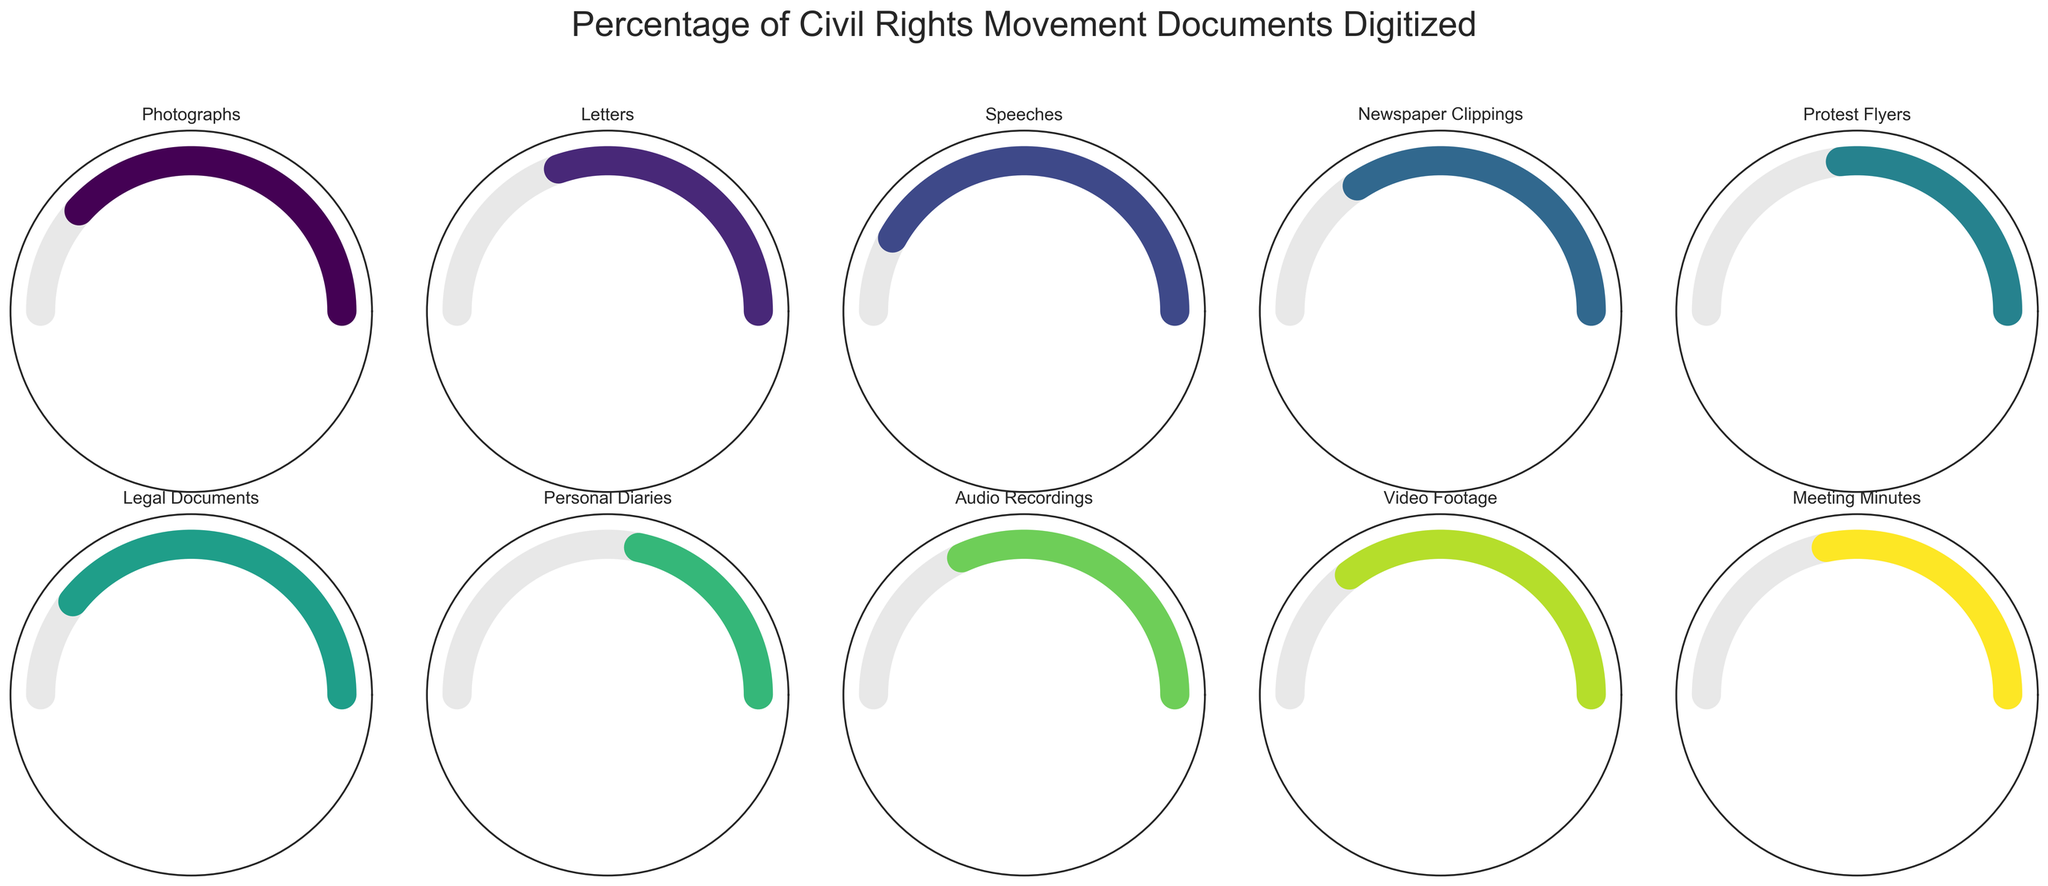What's the highest percentage of digitized documents? The figure shows multiple gauge charts for different document types. By looking at the values displayed in each chart, the highest percentage noted is for Speeches, which is 85%.
Answer: 85% Which document type has the lowest percentage digitized? Glancing at the percentages on the gauge charts, Personal Diaries have the lowest percentage digitized, which is 45%.
Answer: Personal Diaries What's the average percentage of digitized documents across all types? Total of percentages: 78 (Photographs) + 62 (Letters) + 85 (Speeches) + 70 (Newspaper Clippings) + 55 (Protest Flyers) + 80 (Legal Documents) + 45 (Personal Diaries) + 65 (Audio Recordings) + 72 (Video Footage) + 58 (Meeting Minutes) = 670. The number of document types is 10. So, the average is 670/10 = 67%.
Answer: 67% How many document types have a digitization percentage greater than 70%? The document types with a digitization percentage above 70% are Photographs (78%), Speeches (85%), Legal Documents (80%), and Video Footage (72%). Therefore, there are 4 document types.
Answer: 4 Which document types have digitized percentages within 10% of each other? Reviewing the percentages, the following document types have percentages within 10% of each other: Photographs (78%) and Video Footage (72%); Letters (62%), Newspaper Clippings (70%), and Video Footage (72%); Audio Recordings (65%) and Newspaper Clippings (70%).
Answer: Various pairs (Photographs & Video Footage, Letters & Video Footage, etc.) Is the digitization percentage of Legal Documents greater than that of Protest Flyers? The digitization percentage for Legal Documents is 80%, and for Protest Flyers, it is 55%. Hence, Legal Documents have a higher digitization percentage.
Answer: Yes What's the difference in percentage points between the digitization levels of Speeches and Personal Diaries? The percentage digitized for Speeches is 85%, and for Personal Diaries, it is 45%. The difference is 85% - 45% = 40%.
Answer: 40% Which document type has digitization percentages slightly over half-way digitized? Looking for percentages slightly over 50%, Protest Flyers have a digitization percentage of 55%, which is slightly over halfway considered 50%.
Answer: Protest Flyers 